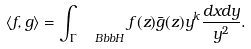Convert formula to latex. <formula><loc_0><loc_0><loc_500><loc_500>\langle f , g \rangle = \int _ { \Gamma \ \ B b b { H } } f ( z ) \bar { g } ( z ) y ^ { k } \frac { d x d y } { y ^ { 2 } } .</formula> 